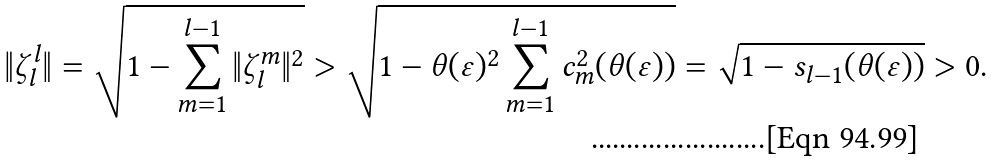Convert formula to latex. <formula><loc_0><loc_0><loc_500><loc_500>\| \zeta ^ { l } _ { l } \| = \sqrt { 1 - \sum _ { m = 1 } ^ { l - 1 } \| \zeta ^ { m } _ { l } \| ^ { 2 } } > \sqrt { 1 - \theta ( \varepsilon ) ^ { 2 } \sum _ { m = 1 } ^ { l - 1 } c _ { m } ^ { 2 } ( \theta ( \varepsilon ) ) } = \sqrt { 1 - s _ { l - 1 } ( \theta ( \varepsilon ) ) } > 0 .</formula> 